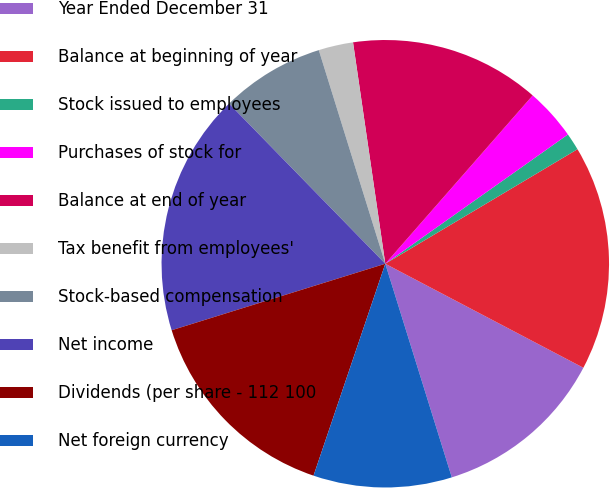<chart> <loc_0><loc_0><loc_500><loc_500><pie_chart><fcel>Year Ended December 31<fcel>Balance at beginning of year<fcel>Stock issued to employees<fcel>Purchases of stock for<fcel>Balance at end of year<fcel>Tax benefit from employees'<fcel>Stock-based compensation<fcel>Net income<fcel>Dividends (per share - 112 100<fcel>Net foreign currency<nl><fcel>12.5%<fcel>16.25%<fcel>1.25%<fcel>3.75%<fcel>13.75%<fcel>2.5%<fcel>7.5%<fcel>17.5%<fcel>15.0%<fcel>10.0%<nl></chart> 